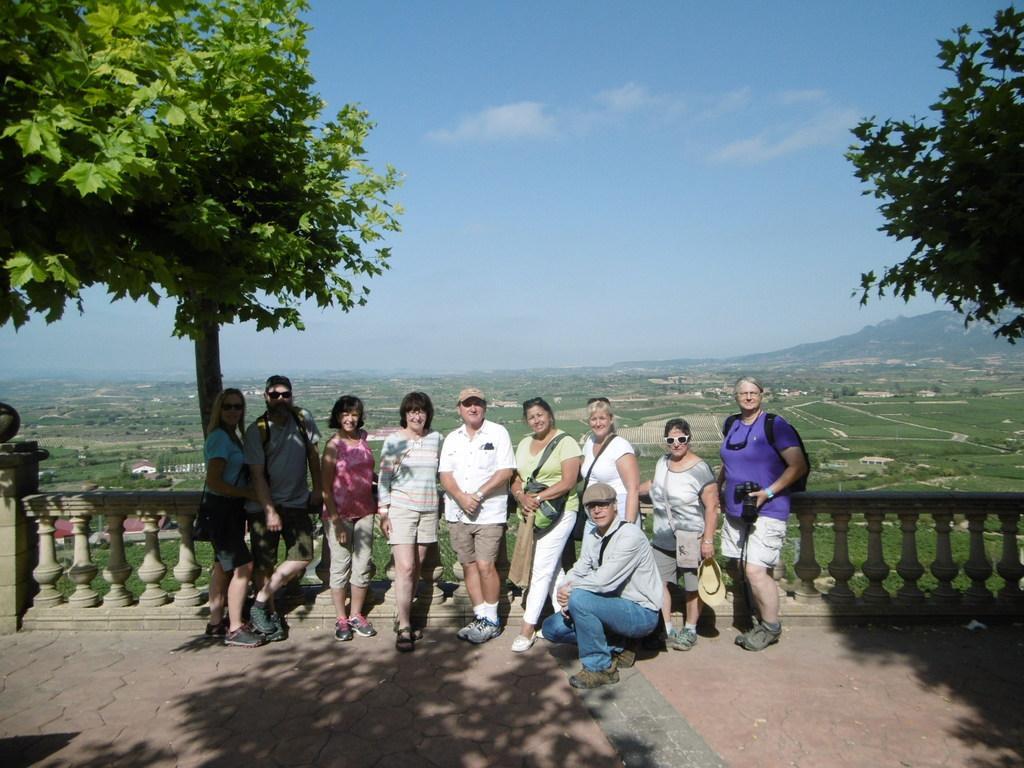How would you summarize this image in a sentence or two? In this picture we can see a few people on the path. There is a fence from left to right. We can see a woman wearing a bag and holding an object in her hand. We can see a few trees and some greenery in the background. 